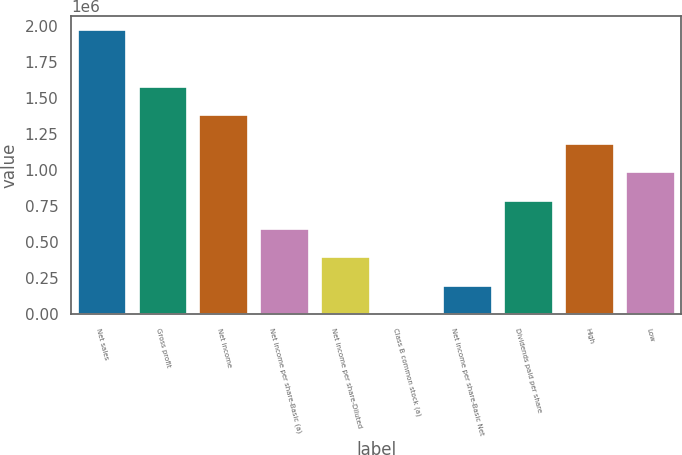<chart> <loc_0><loc_0><loc_500><loc_500><bar_chart><fcel>Net sales<fcel>Gross profit<fcel>Net income<fcel>Net income per share-Basic (a)<fcel>Net income per share-Diluted<fcel>Class B common stock (a)<fcel>Net income per share-Basic Net<fcel>Dividends paid per share<fcel>High<fcel>Low<nl><fcel>1.97024e+06<fcel>1.5762e+06<fcel>1.37917e+06<fcel>591074<fcel>394049<fcel>0.51<fcel>197025<fcel>788098<fcel>1.18215e+06<fcel>985122<nl></chart> 